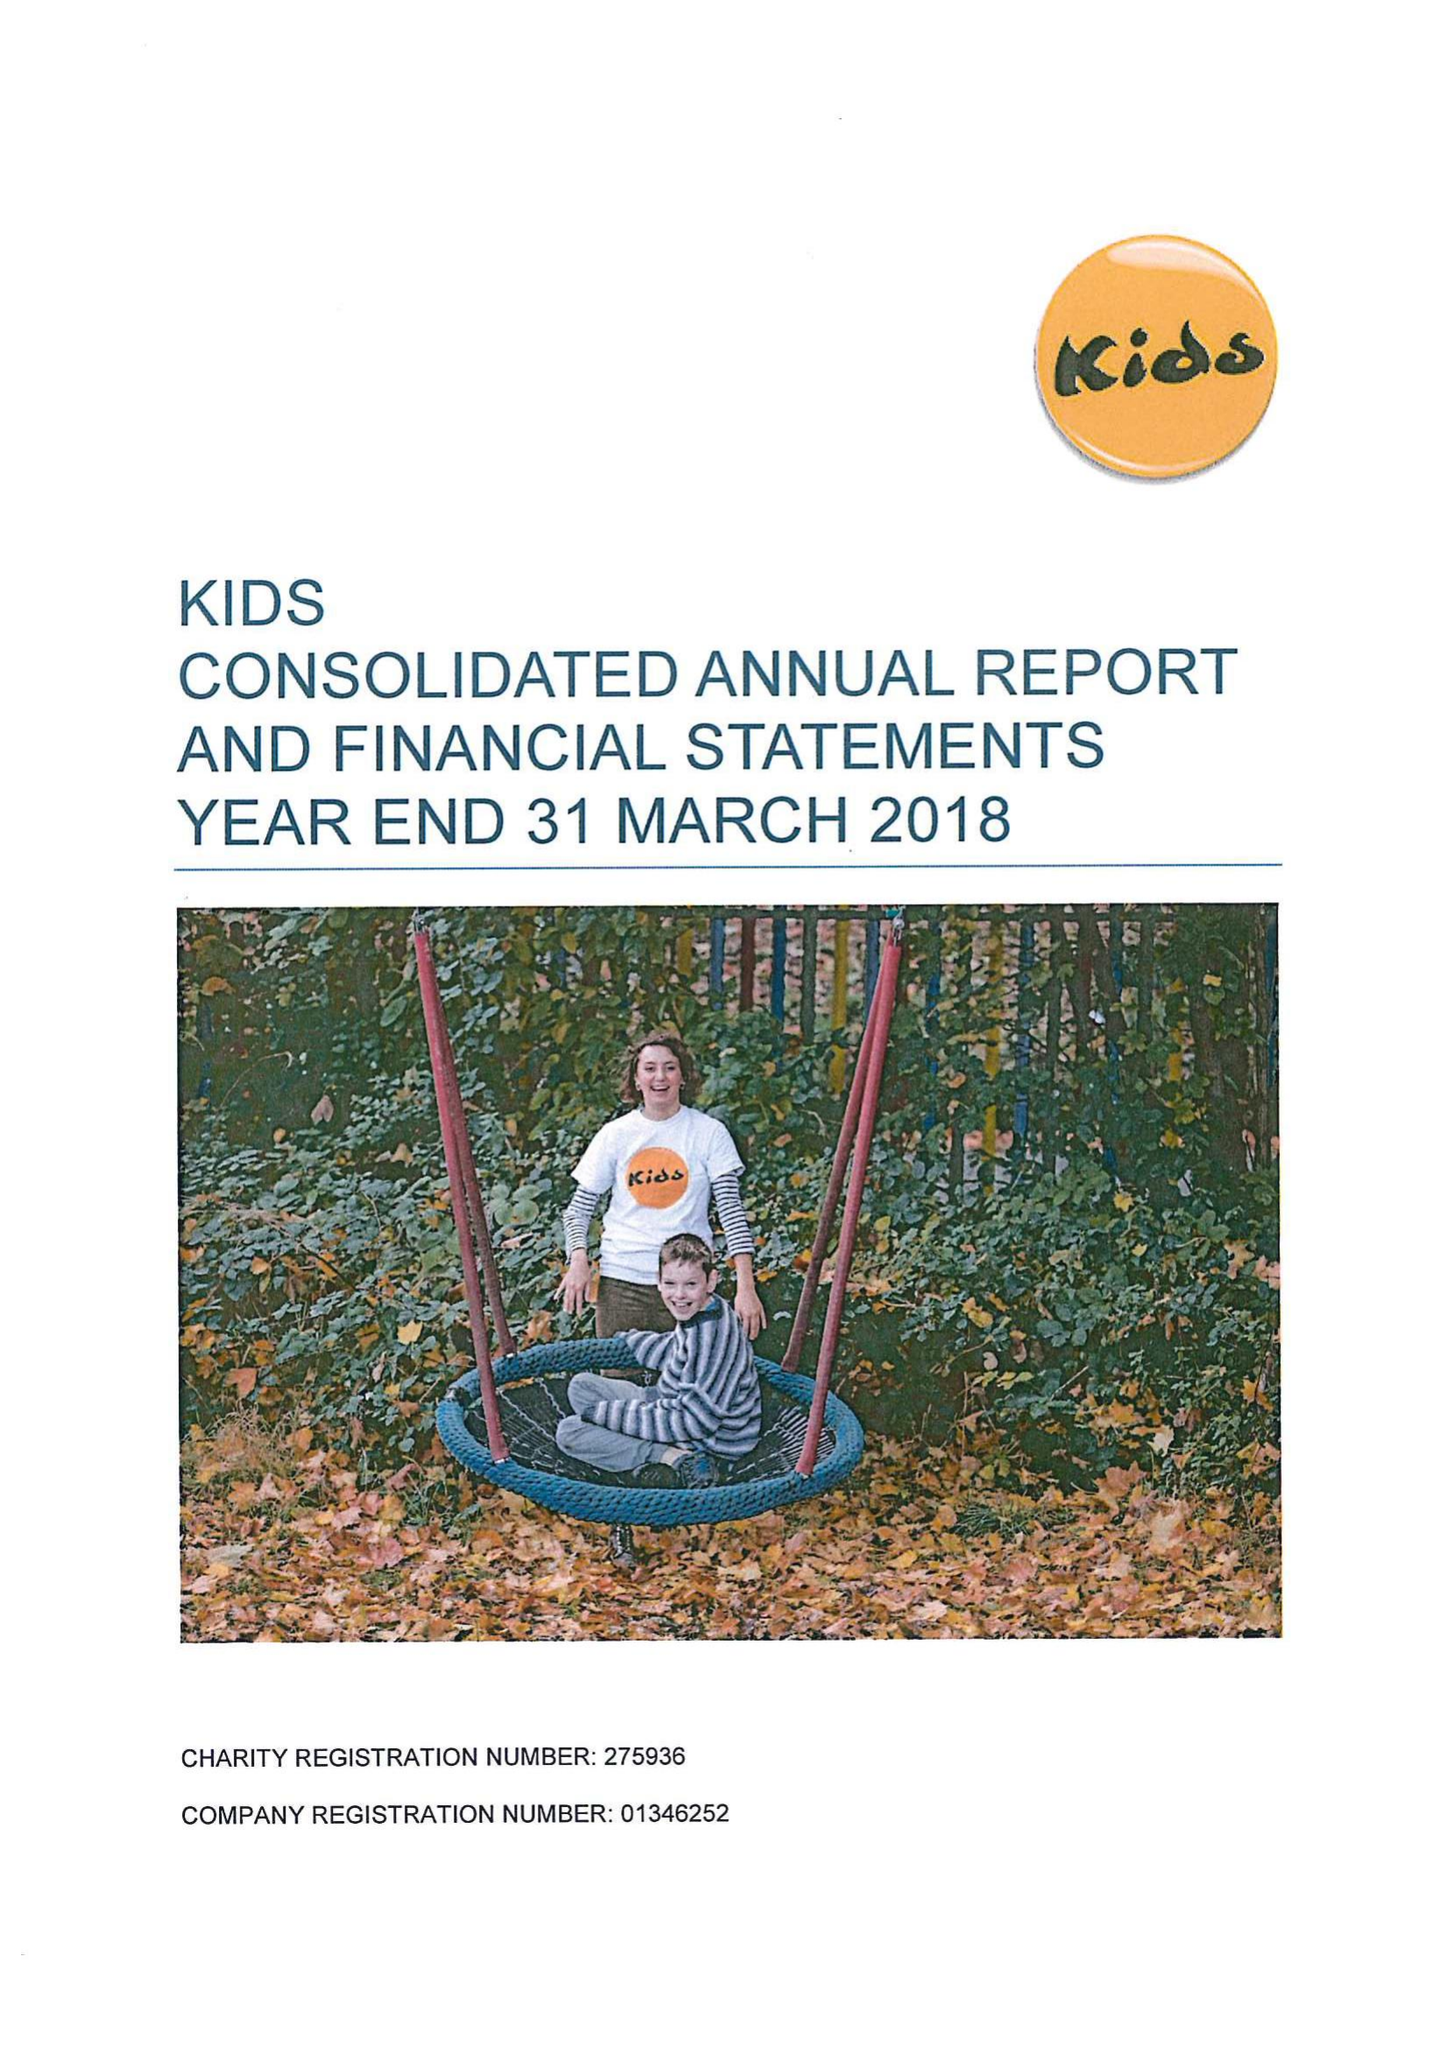What is the value for the address__post_town?
Answer the question using a single word or phrase. LONDON 